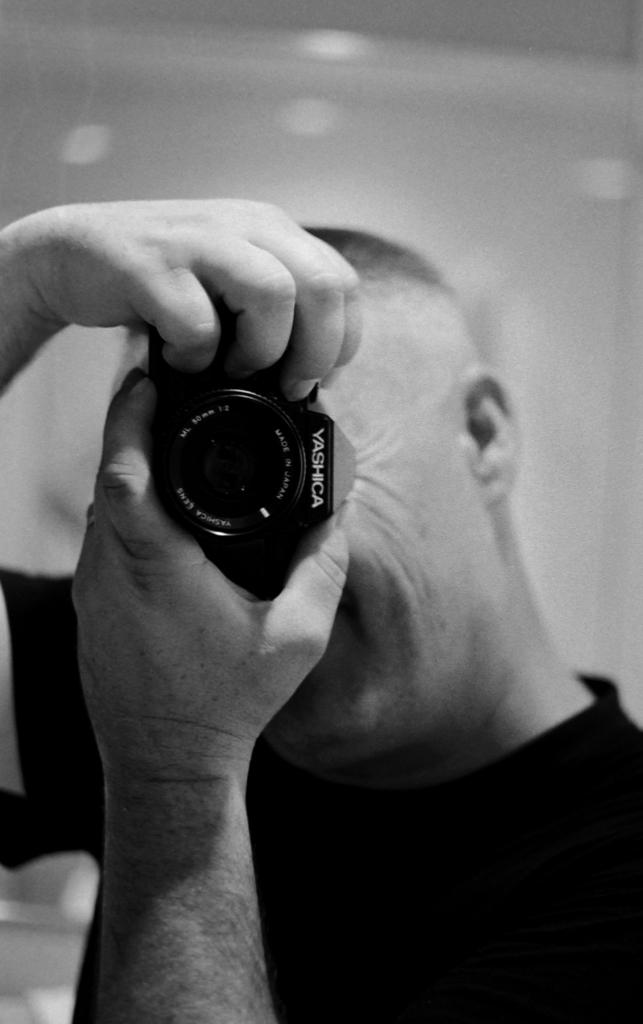Who is the main subject in the image? There is a man in the image. Where is the man positioned in the image? The man is standing in the middle of the image. What is the man holding in his hands? The man is holding a camera in his hands. What can be seen behind the man? There is a wall behind the man. What type of leaf is being used as a prop in the image? There is no leaf present in the image. What kind of tin can be seen on the wall behind the man? There is no tin visible on the wall behind the man. 